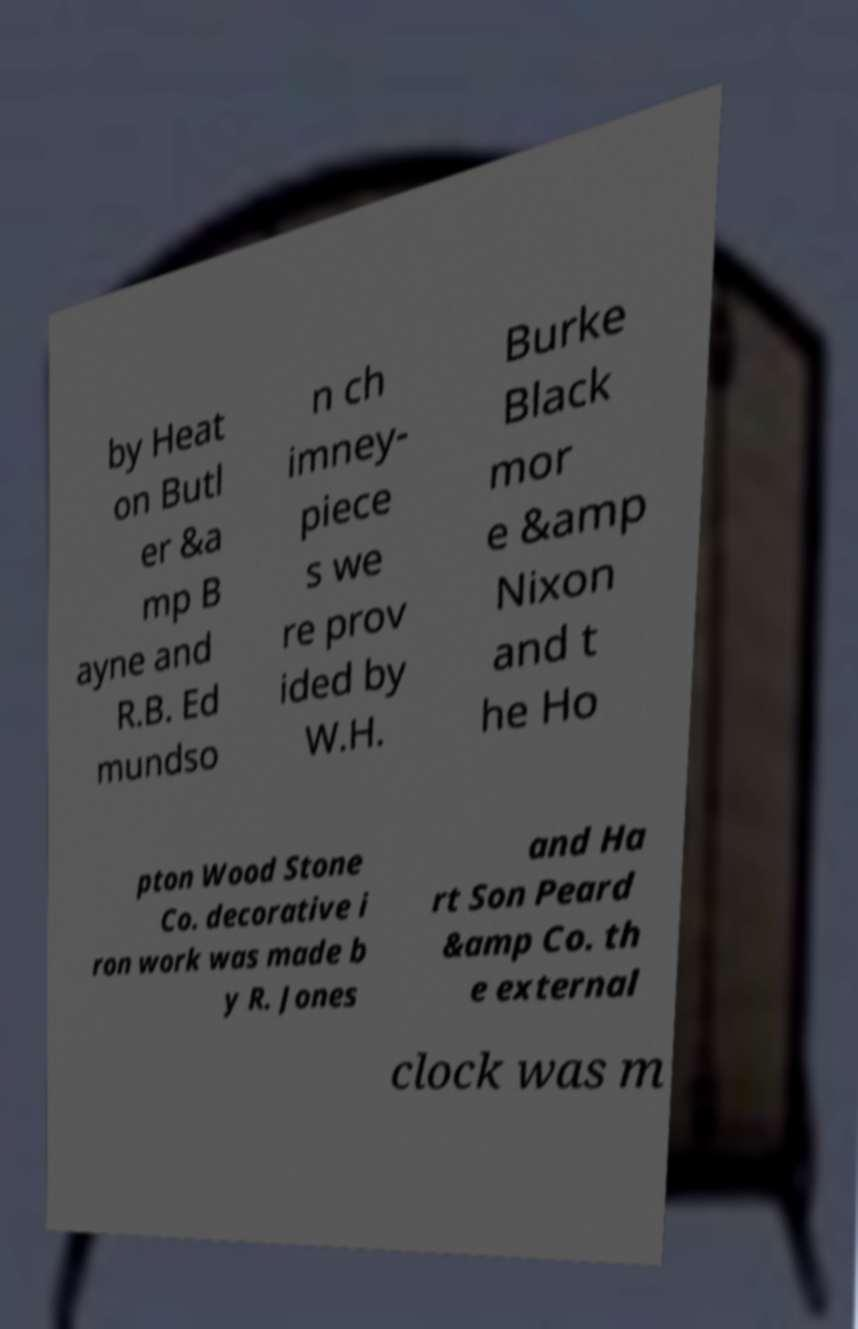There's text embedded in this image that I need extracted. Can you transcribe it verbatim? by Heat on Butl er &a mp B ayne and R.B. Ed mundso n ch imney- piece s we re prov ided by W.H. Burke Black mor e &amp Nixon and t he Ho pton Wood Stone Co. decorative i ron work was made b y R. Jones and Ha rt Son Peard &amp Co. th e external clock was m 